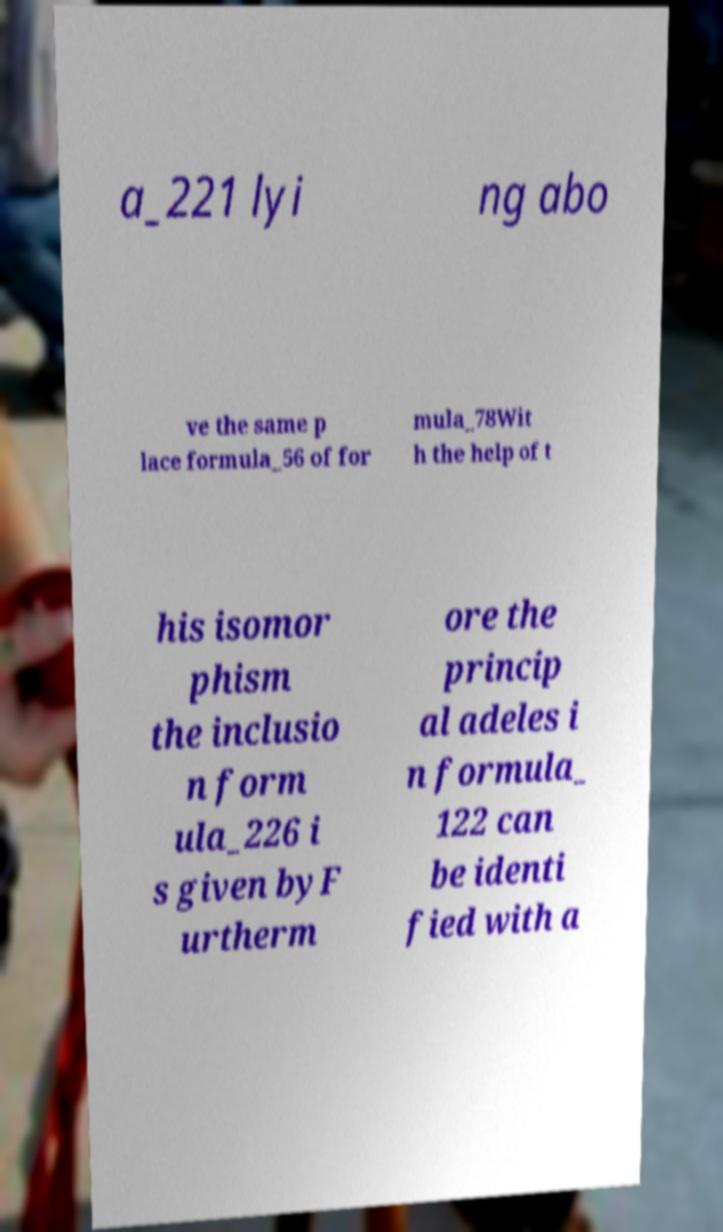Can you accurately transcribe the text from the provided image for me? a_221 lyi ng abo ve the same p lace formula_56 of for mula_78Wit h the help of t his isomor phism the inclusio n form ula_226 i s given byF urtherm ore the princip al adeles i n formula_ 122 can be identi fied with a 